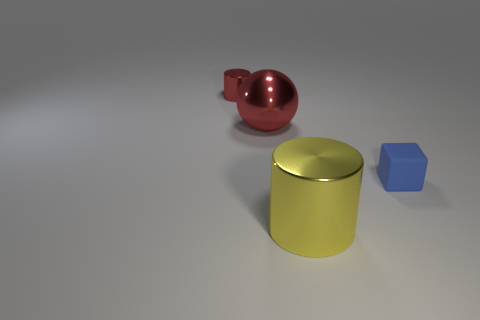There is a sphere; is it the same color as the thing that is to the left of the metallic ball?
Offer a terse response. Yes. What is the size of the sphere that is the same color as the tiny cylinder?
Offer a very short reply. Large. Is the number of metal things that are in front of the matte cube greater than the number of tiny green cylinders?
Your response must be concise. Yes. There is a yellow metallic thing; is its shape the same as the metal object that is to the left of the large shiny ball?
Provide a short and direct response. Yes. How many red shiny cylinders are the same size as the rubber block?
Your response must be concise. 1. There is a cylinder that is behind the cylinder in front of the small cube; how many rubber blocks are behind it?
Offer a terse response. 0. Are there an equal number of shiny balls that are in front of the big yellow metallic cylinder and tiny cylinders that are in front of the metal ball?
Your response must be concise. Yes. What number of red things are the same shape as the large yellow shiny object?
Keep it short and to the point. 1. Is there a large red sphere made of the same material as the red cylinder?
Keep it short and to the point. Yes. What shape is the metallic thing that is the same color as the shiny sphere?
Keep it short and to the point. Cylinder. 